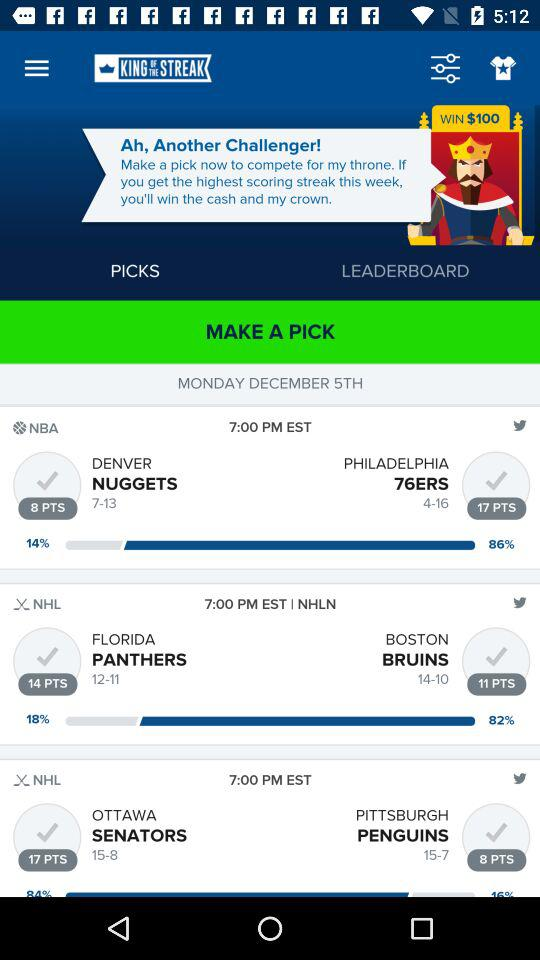What is the application name? The application name is "KING OF THE STREAK". 